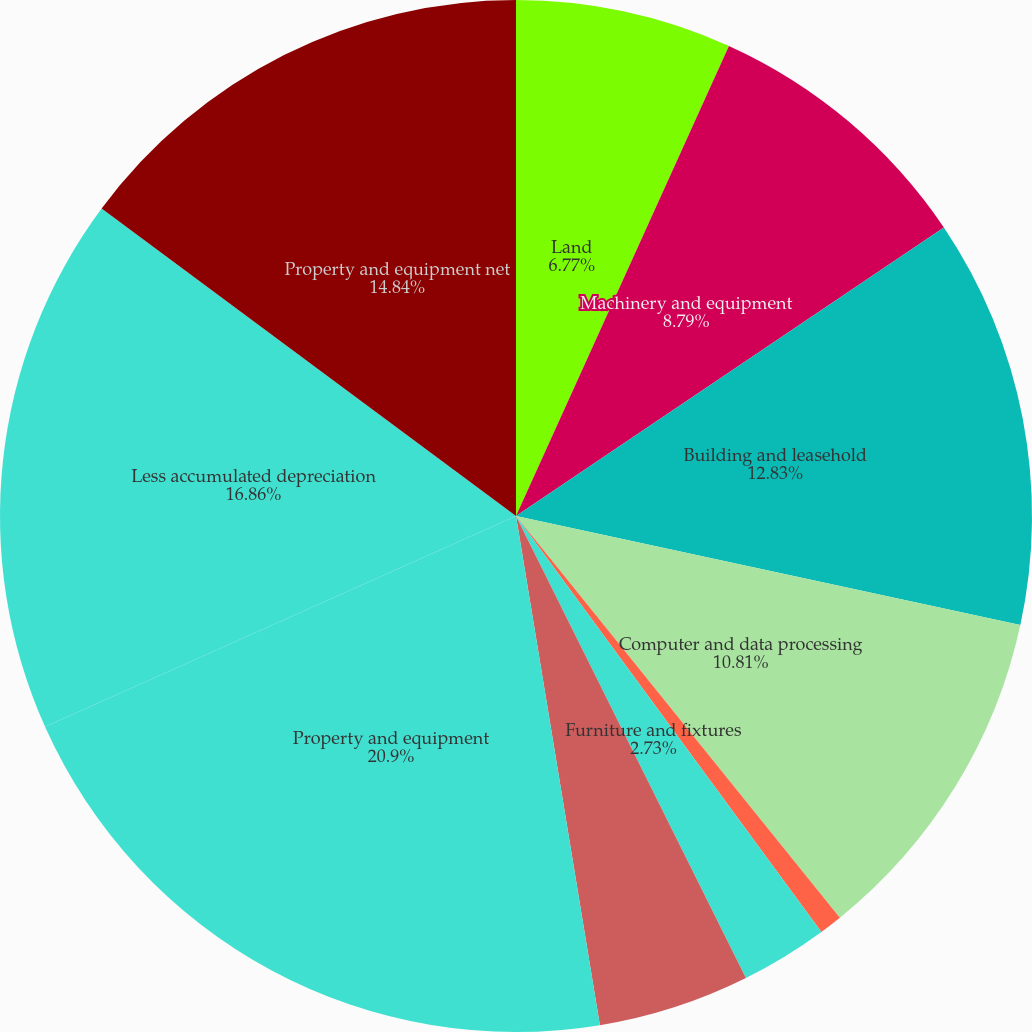Convert chart to OTSL. <chart><loc_0><loc_0><loc_500><loc_500><pie_chart><fcel>Land<fcel>Machinery and equipment<fcel>Building and leasehold<fcel>Computer and data processing<fcel>Computer software<fcel>Furniture and fixtures<fcel>Construction in progress<fcel>Property and equipment<fcel>Less accumulated depreciation<fcel>Property and equipment net<nl><fcel>6.77%<fcel>8.79%<fcel>12.83%<fcel>10.81%<fcel>0.72%<fcel>2.73%<fcel>4.75%<fcel>20.9%<fcel>16.86%<fcel>14.84%<nl></chart> 